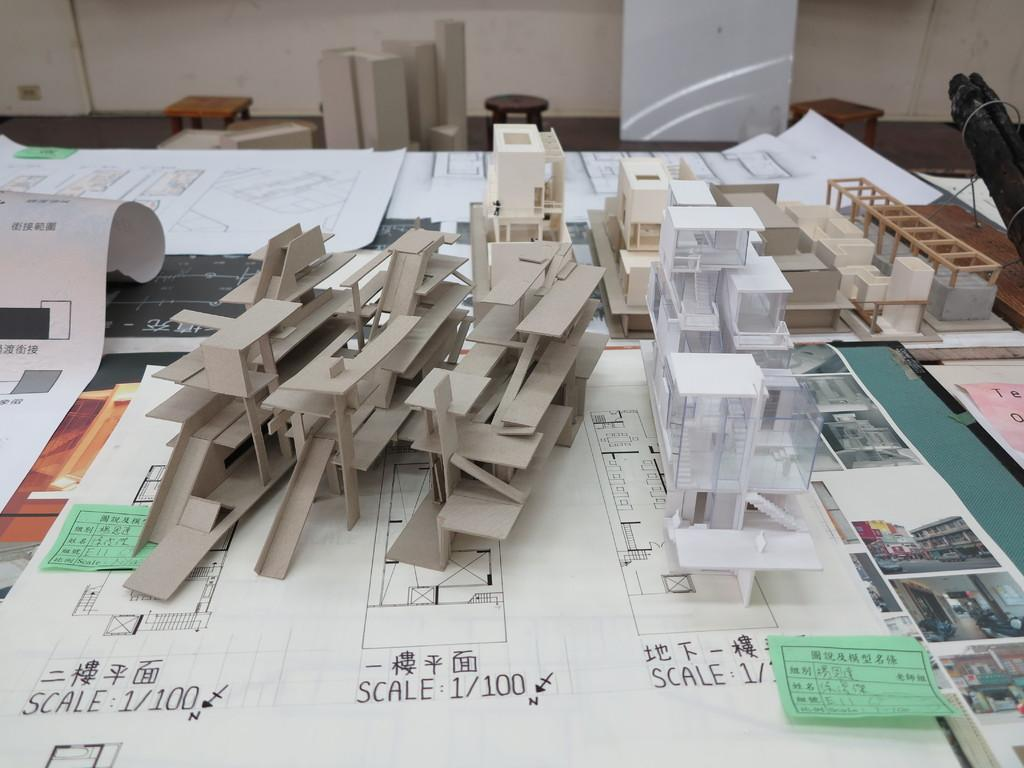How many stools are visible in the image? There are three stools in the image. What can be seen behind the stools? There is a wall in the image. What is on the table in the image? There are paper charts on a table. What else is present on the table's surface? There are objects on the surface of the table. Can you hear the quince breathing in the image? There is no quince present in the image, and therefore it cannot be heard breathing. 